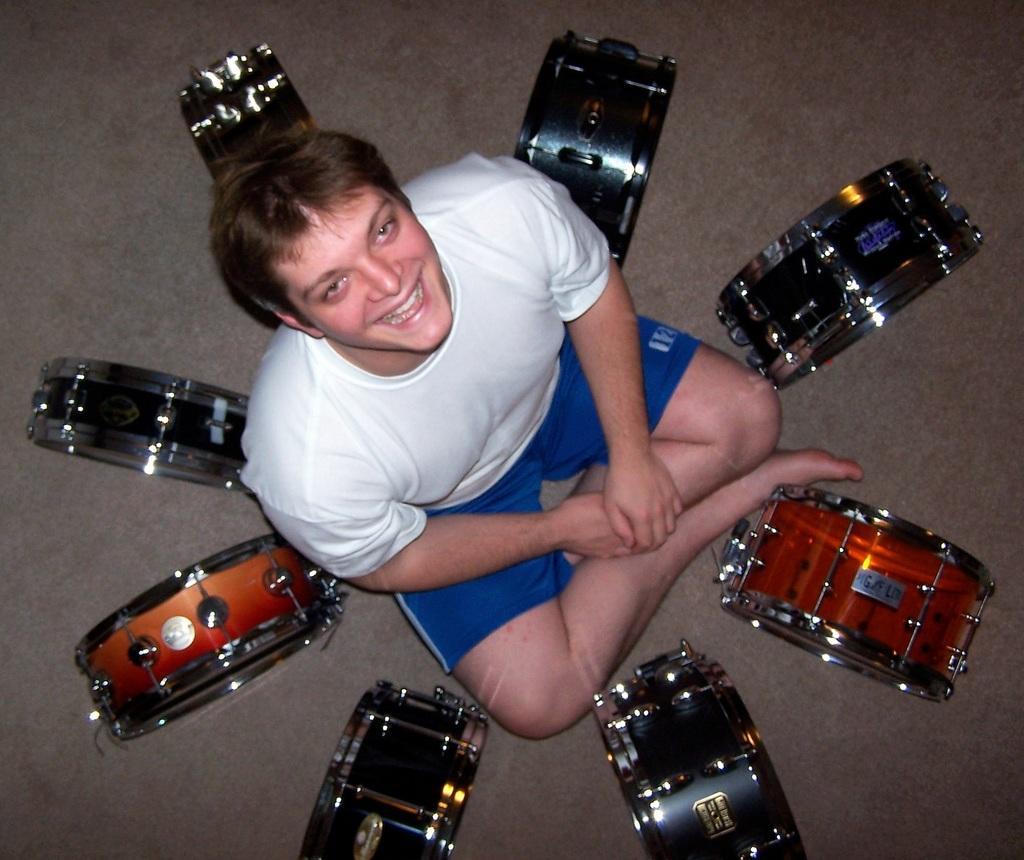Please provide a concise description of this image. In this picture I can see a man in the center, who is sitting on the floor and I see that he is smiling and I see drums around him and I see that he is wearing white color t-shirt and blue shorts. 